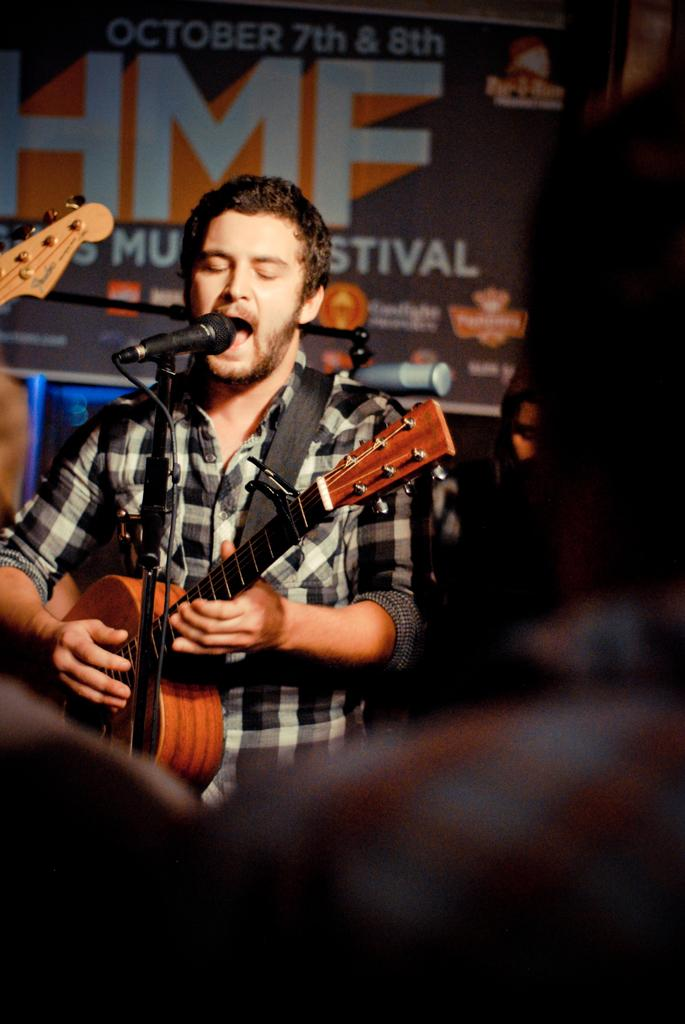What is the man in the image doing? The man in the image is singing. What object is in front of the man? There is a microphone in front of the man. What instrument is the man playing? The man is playing a guitar. What type of legal advice is the man providing in the image? There is no indication in the image that the man is providing legal advice, as he is singing and playing a guitar. Can you see a ghost in the image? There is no ghost present in the image. 